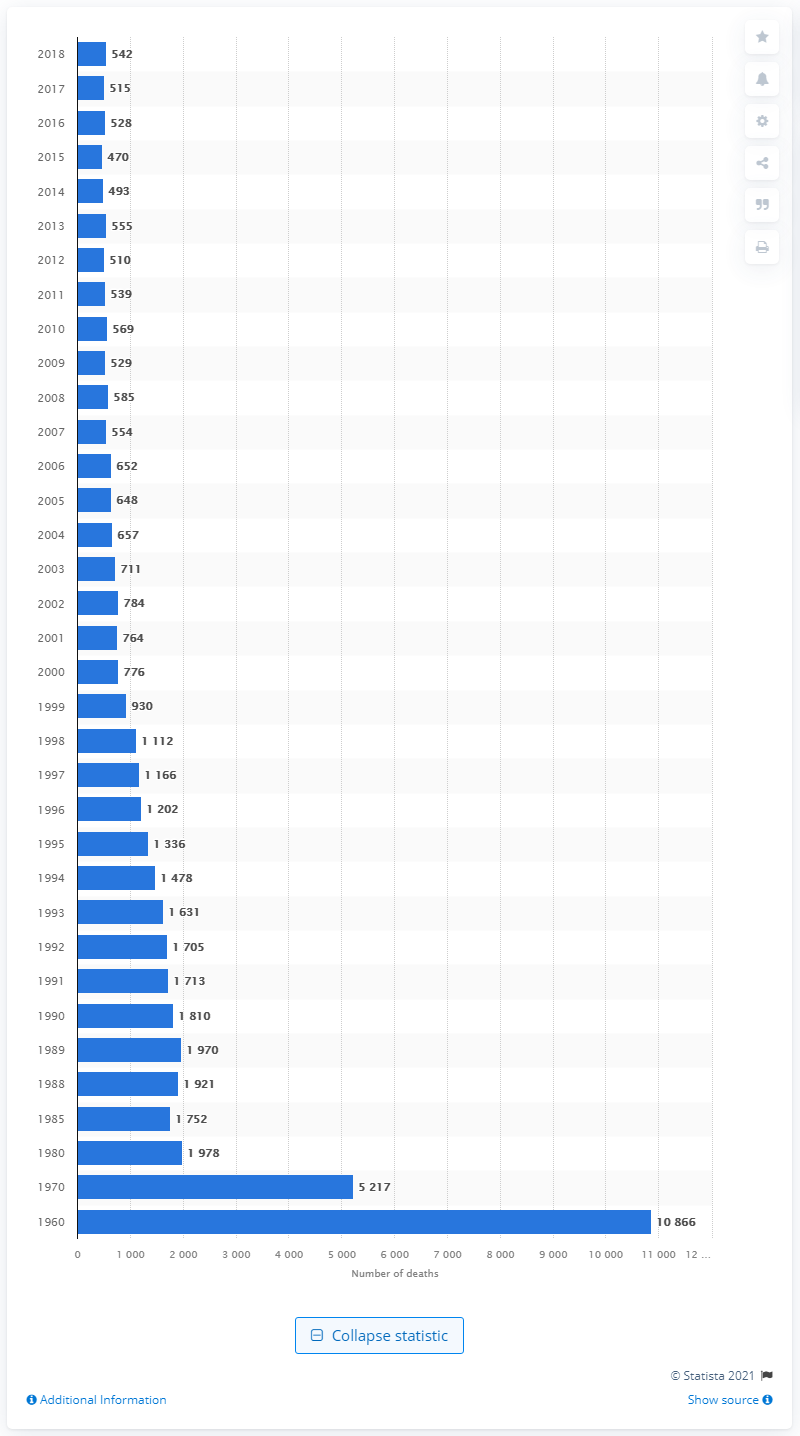Mention a couple of crucial points in this snapshot. In 2018, there were 542 deaths due to tuberculosis. 